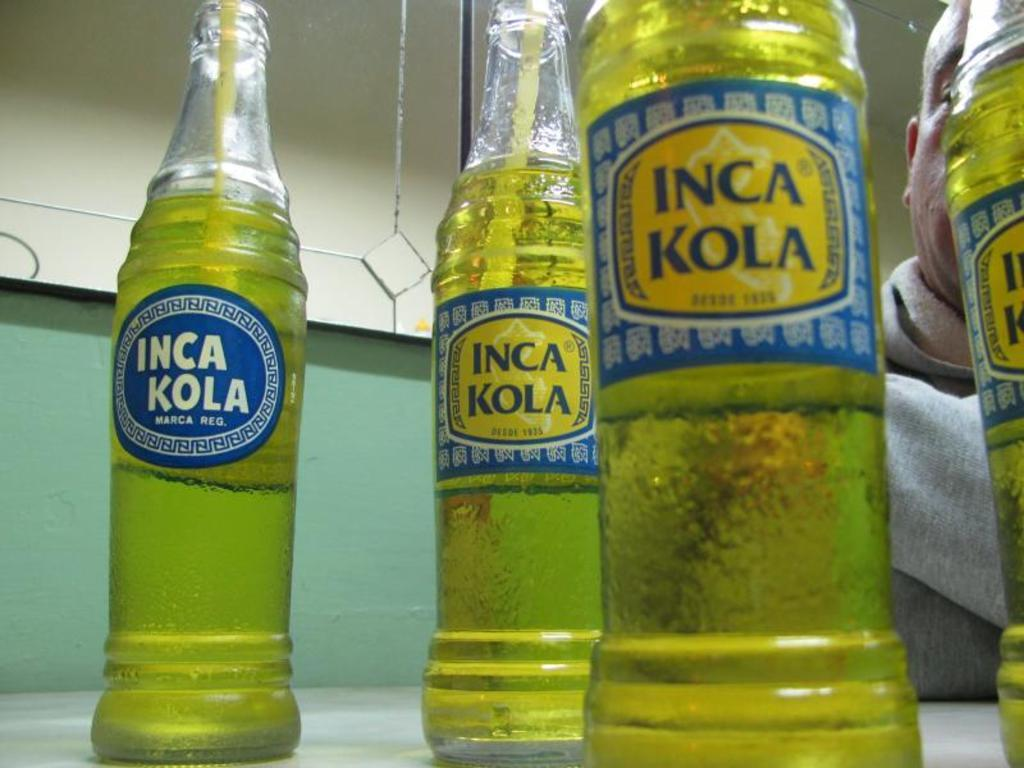<image>
Describe the image concisely. bottles of inca kola standing next to one another on a counter 